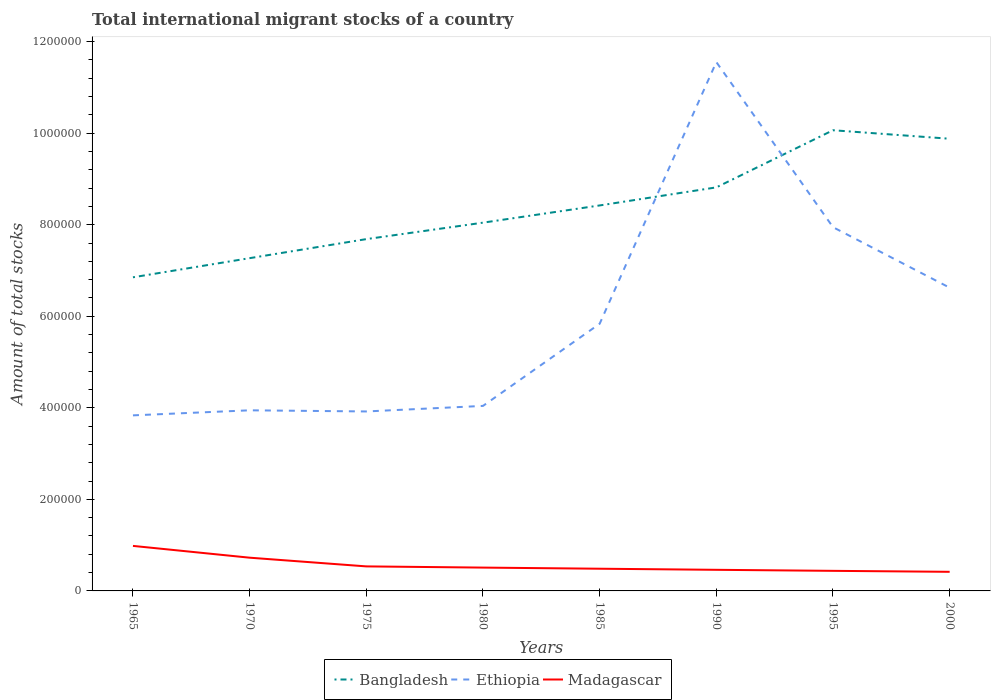How many different coloured lines are there?
Ensure brevity in your answer.  3. Is the number of lines equal to the number of legend labels?
Keep it short and to the point. Yes. Across all years, what is the maximum amount of total stocks in in Madagascar?
Your answer should be very brief. 4.17e+04. In which year was the amount of total stocks in in Ethiopia maximum?
Your answer should be very brief. 1965. What is the total amount of total stocks in in Bangladesh in the graph?
Ensure brevity in your answer.  -3.76e+04. What is the difference between the highest and the second highest amount of total stocks in in Bangladesh?
Ensure brevity in your answer.  3.21e+05. Is the amount of total stocks in in Bangladesh strictly greater than the amount of total stocks in in Ethiopia over the years?
Your response must be concise. No. How many lines are there?
Offer a very short reply. 3. Does the graph contain grids?
Keep it short and to the point. No. What is the title of the graph?
Give a very brief answer. Total international migrant stocks of a country. Does "Cuba" appear as one of the legend labels in the graph?
Ensure brevity in your answer.  No. What is the label or title of the Y-axis?
Your answer should be compact. Amount of total stocks. What is the Amount of total stocks of Bangladesh in 1965?
Give a very brief answer. 6.85e+05. What is the Amount of total stocks in Ethiopia in 1965?
Your answer should be very brief. 3.84e+05. What is the Amount of total stocks in Madagascar in 1965?
Provide a succinct answer. 9.84e+04. What is the Amount of total stocks in Bangladesh in 1970?
Keep it short and to the point. 7.27e+05. What is the Amount of total stocks of Ethiopia in 1970?
Provide a succinct answer. 3.95e+05. What is the Amount of total stocks in Madagascar in 1970?
Ensure brevity in your answer.  7.26e+04. What is the Amount of total stocks of Bangladesh in 1975?
Give a very brief answer. 7.69e+05. What is the Amount of total stocks in Ethiopia in 1975?
Ensure brevity in your answer.  3.92e+05. What is the Amount of total stocks of Madagascar in 1975?
Offer a terse response. 5.36e+04. What is the Amount of total stocks of Bangladesh in 1980?
Your answer should be very brief. 8.05e+05. What is the Amount of total stocks in Ethiopia in 1980?
Provide a succinct answer. 4.04e+05. What is the Amount of total stocks of Madagascar in 1980?
Provide a succinct answer. 5.10e+04. What is the Amount of total stocks of Bangladesh in 1985?
Give a very brief answer. 8.42e+05. What is the Amount of total stocks of Ethiopia in 1985?
Your answer should be very brief. 5.84e+05. What is the Amount of total stocks of Madagascar in 1985?
Make the answer very short. 4.85e+04. What is the Amount of total stocks in Bangladesh in 1990?
Ensure brevity in your answer.  8.82e+05. What is the Amount of total stocks of Ethiopia in 1990?
Your answer should be compact. 1.16e+06. What is the Amount of total stocks of Madagascar in 1990?
Provide a succinct answer. 4.61e+04. What is the Amount of total stocks in Bangladesh in 1995?
Give a very brief answer. 1.01e+06. What is the Amount of total stocks in Ethiopia in 1995?
Provide a succinct answer. 7.95e+05. What is the Amount of total stocks of Madagascar in 1995?
Provide a succinct answer. 4.39e+04. What is the Amount of total stocks in Bangladesh in 2000?
Offer a very short reply. 9.88e+05. What is the Amount of total stocks of Ethiopia in 2000?
Provide a short and direct response. 6.62e+05. What is the Amount of total stocks of Madagascar in 2000?
Ensure brevity in your answer.  4.17e+04. Across all years, what is the maximum Amount of total stocks of Bangladesh?
Make the answer very short. 1.01e+06. Across all years, what is the maximum Amount of total stocks in Ethiopia?
Give a very brief answer. 1.16e+06. Across all years, what is the maximum Amount of total stocks of Madagascar?
Provide a succinct answer. 9.84e+04. Across all years, what is the minimum Amount of total stocks in Bangladesh?
Give a very brief answer. 6.85e+05. Across all years, what is the minimum Amount of total stocks in Ethiopia?
Provide a succinct answer. 3.84e+05. Across all years, what is the minimum Amount of total stocks of Madagascar?
Your answer should be compact. 4.17e+04. What is the total Amount of total stocks in Bangladesh in the graph?
Offer a terse response. 6.70e+06. What is the total Amount of total stocks in Ethiopia in the graph?
Make the answer very short. 4.77e+06. What is the total Amount of total stocks in Madagascar in the graph?
Your answer should be very brief. 4.56e+05. What is the difference between the Amount of total stocks of Bangladesh in 1965 and that in 1970?
Provide a short and direct response. -4.18e+04. What is the difference between the Amount of total stocks in Ethiopia in 1965 and that in 1970?
Offer a terse response. -1.10e+04. What is the difference between the Amount of total stocks in Madagascar in 1965 and that in 1970?
Provide a succinct answer. 2.58e+04. What is the difference between the Amount of total stocks in Bangladesh in 1965 and that in 1975?
Keep it short and to the point. -8.34e+04. What is the difference between the Amount of total stocks of Ethiopia in 1965 and that in 1975?
Keep it short and to the point. -8531. What is the difference between the Amount of total stocks in Madagascar in 1965 and that in 1975?
Keep it short and to the point. 4.48e+04. What is the difference between the Amount of total stocks in Bangladesh in 1965 and that in 1980?
Provide a short and direct response. -1.19e+05. What is the difference between the Amount of total stocks of Ethiopia in 1965 and that in 1980?
Offer a very short reply. -2.06e+04. What is the difference between the Amount of total stocks in Madagascar in 1965 and that in 1980?
Make the answer very short. 4.74e+04. What is the difference between the Amount of total stocks of Bangladesh in 1965 and that in 1985?
Keep it short and to the point. -1.57e+05. What is the difference between the Amount of total stocks of Ethiopia in 1965 and that in 1985?
Offer a very short reply. -2.00e+05. What is the difference between the Amount of total stocks of Madagascar in 1965 and that in 1985?
Give a very brief answer. 4.99e+04. What is the difference between the Amount of total stocks in Bangladesh in 1965 and that in 1990?
Provide a short and direct response. -1.96e+05. What is the difference between the Amount of total stocks in Ethiopia in 1965 and that in 1990?
Give a very brief answer. -7.72e+05. What is the difference between the Amount of total stocks of Madagascar in 1965 and that in 1990?
Keep it short and to the point. 5.22e+04. What is the difference between the Amount of total stocks in Bangladesh in 1965 and that in 1995?
Your response must be concise. -3.21e+05. What is the difference between the Amount of total stocks of Ethiopia in 1965 and that in 1995?
Give a very brief answer. -4.11e+05. What is the difference between the Amount of total stocks of Madagascar in 1965 and that in 1995?
Ensure brevity in your answer.  5.45e+04. What is the difference between the Amount of total stocks of Bangladesh in 1965 and that in 2000?
Offer a very short reply. -3.03e+05. What is the difference between the Amount of total stocks of Ethiopia in 1965 and that in 2000?
Offer a very short reply. -2.79e+05. What is the difference between the Amount of total stocks in Madagascar in 1965 and that in 2000?
Provide a short and direct response. 5.66e+04. What is the difference between the Amount of total stocks of Bangladesh in 1970 and that in 1975?
Your response must be concise. -4.16e+04. What is the difference between the Amount of total stocks in Ethiopia in 1970 and that in 1975?
Keep it short and to the point. 2500. What is the difference between the Amount of total stocks of Madagascar in 1970 and that in 1975?
Offer a very short reply. 1.90e+04. What is the difference between the Amount of total stocks in Bangladesh in 1970 and that in 1980?
Provide a short and direct response. -7.75e+04. What is the difference between the Amount of total stocks of Ethiopia in 1970 and that in 1980?
Ensure brevity in your answer.  -9610. What is the difference between the Amount of total stocks in Madagascar in 1970 and that in 1980?
Make the answer very short. 2.16e+04. What is the difference between the Amount of total stocks of Bangladesh in 1970 and that in 1985?
Keep it short and to the point. -1.15e+05. What is the difference between the Amount of total stocks of Ethiopia in 1970 and that in 1985?
Your response must be concise. -1.89e+05. What is the difference between the Amount of total stocks in Madagascar in 1970 and that in 1985?
Offer a terse response. 2.41e+04. What is the difference between the Amount of total stocks in Bangladesh in 1970 and that in 1990?
Your response must be concise. -1.55e+05. What is the difference between the Amount of total stocks of Ethiopia in 1970 and that in 1990?
Offer a very short reply. -7.61e+05. What is the difference between the Amount of total stocks in Madagascar in 1970 and that in 1990?
Make the answer very short. 2.65e+04. What is the difference between the Amount of total stocks of Bangladesh in 1970 and that in 1995?
Provide a succinct answer. -2.79e+05. What is the difference between the Amount of total stocks of Ethiopia in 1970 and that in 1995?
Your response must be concise. -4.00e+05. What is the difference between the Amount of total stocks of Madagascar in 1970 and that in 1995?
Keep it short and to the point. 2.87e+04. What is the difference between the Amount of total stocks of Bangladesh in 1970 and that in 2000?
Provide a short and direct response. -2.61e+05. What is the difference between the Amount of total stocks of Ethiopia in 1970 and that in 2000?
Provide a short and direct response. -2.68e+05. What is the difference between the Amount of total stocks in Madagascar in 1970 and that in 2000?
Provide a short and direct response. 3.09e+04. What is the difference between the Amount of total stocks of Bangladesh in 1975 and that in 1980?
Ensure brevity in your answer.  -3.59e+04. What is the difference between the Amount of total stocks in Ethiopia in 1975 and that in 1980?
Your response must be concise. -1.21e+04. What is the difference between the Amount of total stocks of Madagascar in 1975 and that in 1980?
Your answer should be compact. 2614. What is the difference between the Amount of total stocks in Bangladesh in 1975 and that in 1985?
Keep it short and to the point. -7.36e+04. What is the difference between the Amount of total stocks in Ethiopia in 1975 and that in 1985?
Make the answer very short. -1.92e+05. What is the difference between the Amount of total stocks in Madagascar in 1975 and that in 1985?
Your answer should be very brief. 5101. What is the difference between the Amount of total stocks in Bangladesh in 1975 and that in 1990?
Offer a very short reply. -1.13e+05. What is the difference between the Amount of total stocks in Ethiopia in 1975 and that in 1990?
Provide a succinct answer. -7.63e+05. What is the difference between the Amount of total stocks in Madagascar in 1975 and that in 1990?
Offer a terse response. 7466. What is the difference between the Amount of total stocks of Bangladesh in 1975 and that in 1995?
Offer a terse response. -2.38e+05. What is the difference between the Amount of total stocks in Ethiopia in 1975 and that in 1995?
Your answer should be very brief. -4.03e+05. What is the difference between the Amount of total stocks in Madagascar in 1975 and that in 1995?
Offer a terse response. 9716. What is the difference between the Amount of total stocks in Bangladesh in 1975 and that in 2000?
Keep it short and to the point. -2.19e+05. What is the difference between the Amount of total stocks of Ethiopia in 1975 and that in 2000?
Your response must be concise. -2.70e+05. What is the difference between the Amount of total stocks in Madagascar in 1975 and that in 2000?
Give a very brief answer. 1.19e+04. What is the difference between the Amount of total stocks of Bangladesh in 1980 and that in 1985?
Make the answer very short. -3.76e+04. What is the difference between the Amount of total stocks of Ethiopia in 1980 and that in 1985?
Make the answer very short. -1.79e+05. What is the difference between the Amount of total stocks of Madagascar in 1980 and that in 1985?
Your answer should be very brief. 2487. What is the difference between the Amount of total stocks of Bangladesh in 1980 and that in 1990?
Provide a succinct answer. -7.71e+04. What is the difference between the Amount of total stocks of Ethiopia in 1980 and that in 1990?
Your response must be concise. -7.51e+05. What is the difference between the Amount of total stocks in Madagascar in 1980 and that in 1990?
Ensure brevity in your answer.  4852. What is the difference between the Amount of total stocks of Bangladesh in 1980 and that in 1995?
Make the answer very short. -2.02e+05. What is the difference between the Amount of total stocks of Ethiopia in 1980 and that in 1995?
Your answer should be very brief. -3.90e+05. What is the difference between the Amount of total stocks of Madagascar in 1980 and that in 1995?
Ensure brevity in your answer.  7102. What is the difference between the Amount of total stocks in Bangladesh in 1980 and that in 2000?
Offer a terse response. -1.83e+05. What is the difference between the Amount of total stocks in Ethiopia in 1980 and that in 2000?
Keep it short and to the point. -2.58e+05. What is the difference between the Amount of total stocks of Madagascar in 1980 and that in 2000?
Your response must be concise. 9242. What is the difference between the Amount of total stocks in Bangladesh in 1985 and that in 1990?
Your answer should be compact. -3.95e+04. What is the difference between the Amount of total stocks of Ethiopia in 1985 and that in 1990?
Offer a terse response. -5.72e+05. What is the difference between the Amount of total stocks in Madagascar in 1985 and that in 1990?
Provide a short and direct response. 2365. What is the difference between the Amount of total stocks of Bangladesh in 1985 and that in 1995?
Provide a short and direct response. -1.64e+05. What is the difference between the Amount of total stocks of Ethiopia in 1985 and that in 1995?
Give a very brief answer. -2.11e+05. What is the difference between the Amount of total stocks in Madagascar in 1985 and that in 1995?
Ensure brevity in your answer.  4615. What is the difference between the Amount of total stocks of Bangladesh in 1985 and that in 2000?
Offer a terse response. -1.46e+05. What is the difference between the Amount of total stocks in Ethiopia in 1985 and that in 2000?
Your answer should be very brief. -7.88e+04. What is the difference between the Amount of total stocks in Madagascar in 1985 and that in 2000?
Make the answer very short. 6755. What is the difference between the Amount of total stocks in Bangladesh in 1990 and that in 1995?
Your answer should be very brief. -1.25e+05. What is the difference between the Amount of total stocks in Ethiopia in 1990 and that in 1995?
Your response must be concise. 3.61e+05. What is the difference between the Amount of total stocks of Madagascar in 1990 and that in 1995?
Offer a very short reply. 2250. What is the difference between the Amount of total stocks in Bangladesh in 1990 and that in 2000?
Your response must be concise. -1.06e+05. What is the difference between the Amount of total stocks of Ethiopia in 1990 and that in 2000?
Make the answer very short. 4.93e+05. What is the difference between the Amount of total stocks of Madagascar in 1990 and that in 2000?
Offer a terse response. 4390. What is the difference between the Amount of total stocks in Bangladesh in 1995 and that in 2000?
Give a very brief answer. 1.86e+04. What is the difference between the Amount of total stocks of Ethiopia in 1995 and that in 2000?
Provide a short and direct response. 1.32e+05. What is the difference between the Amount of total stocks in Madagascar in 1995 and that in 2000?
Your answer should be very brief. 2140. What is the difference between the Amount of total stocks of Bangladesh in 1965 and the Amount of total stocks of Ethiopia in 1970?
Your answer should be very brief. 2.91e+05. What is the difference between the Amount of total stocks in Bangladesh in 1965 and the Amount of total stocks in Madagascar in 1970?
Make the answer very short. 6.13e+05. What is the difference between the Amount of total stocks in Ethiopia in 1965 and the Amount of total stocks in Madagascar in 1970?
Offer a terse response. 3.11e+05. What is the difference between the Amount of total stocks in Bangladesh in 1965 and the Amount of total stocks in Ethiopia in 1975?
Keep it short and to the point. 2.93e+05. What is the difference between the Amount of total stocks of Bangladesh in 1965 and the Amount of total stocks of Madagascar in 1975?
Offer a terse response. 6.32e+05. What is the difference between the Amount of total stocks in Ethiopia in 1965 and the Amount of total stocks in Madagascar in 1975?
Ensure brevity in your answer.  3.30e+05. What is the difference between the Amount of total stocks in Bangladesh in 1965 and the Amount of total stocks in Ethiopia in 1980?
Make the answer very short. 2.81e+05. What is the difference between the Amount of total stocks in Bangladesh in 1965 and the Amount of total stocks in Madagascar in 1980?
Keep it short and to the point. 6.34e+05. What is the difference between the Amount of total stocks in Ethiopia in 1965 and the Amount of total stocks in Madagascar in 1980?
Your answer should be very brief. 3.33e+05. What is the difference between the Amount of total stocks in Bangladesh in 1965 and the Amount of total stocks in Ethiopia in 1985?
Keep it short and to the point. 1.02e+05. What is the difference between the Amount of total stocks of Bangladesh in 1965 and the Amount of total stocks of Madagascar in 1985?
Make the answer very short. 6.37e+05. What is the difference between the Amount of total stocks in Ethiopia in 1965 and the Amount of total stocks in Madagascar in 1985?
Your response must be concise. 3.35e+05. What is the difference between the Amount of total stocks of Bangladesh in 1965 and the Amount of total stocks of Ethiopia in 1990?
Provide a short and direct response. -4.70e+05. What is the difference between the Amount of total stocks in Bangladesh in 1965 and the Amount of total stocks in Madagascar in 1990?
Your answer should be very brief. 6.39e+05. What is the difference between the Amount of total stocks of Ethiopia in 1965 and the Amount of total stocks of Madagascar in 1990?
Ensure brevity in your answer.  3.37e+05. What is the difference between the Amount of total stocks of Bangladesh in 1965 and the Amount of total stocks of Ethiopia in 1995?
Your answer should be compact. -1.10e+05. What is the difference between the Amount of total stocks of Bangladesh in 1965 and the Amount of total stocks of Madagascar in 1995?
Offer a very short reply. 6.41e+05. What is the difference between the Amount of total stocks in Ethiopia in 1965 and the Amount of total stocks in Madagascar in 1995?
Offer a very short reply. 3.40e+05. What is the difference between the Amount of total stocks of Bangladesh in 1965 and the Amount of total stocks of Ethiopia in 2000?
Your answer should be very brief. 2.27e+04. What is the difference between the Amount of total stocks of Bangladesh in 1965 and the Amount of total stocks of Madagascar in 2000?
Provide a short and direct response. 6.43e+05. What is the difference between the Amount of total stocks in Ethiopia in 1965 and the Amount of total stocks in Madagascar in 2000?
Provide a succinct answer. 3.42e+05. What is the difference between the Amount of total stocks in Bangladesh in 1970 and the Amount of total stocks in Ethiopia in 1975?
Ensure brevity in your answer.  3.35e+05. What is the difference between the Amount of total stocks of Bangladesh in 1970 and the Amount of total stocks of Madagascar in 1975?
Your response must be concise. 6.73e+05. What is the difference between the Amount of total stocks of Ethiopia in 1970 and the Amount of total stocks of Madagascar in 1975?
Offer a very short reply. 3.41e+05. What is the difference between the Amount of total stocks in Bangladesh in 1970 and the Amount of total stocks in Ethiopia in 1980?
Your response must be concise. 3.23e+05. What is the difference between the Amount of total stocks in Bangladesh in 1970 and the Amount of total stocks in Madagascar in 1980?
Provide a succinct answer. 6.76e+05. What is the difference between the Amount of total stocks of Ethiopia in 1970 and the Amount of total stocks of Madagascar in 1980?
Provide a succinct answer. 3.44e+05. What is the difference between the Amount of total stocks of Bangladesh in 1970 and the Amount of total stocks of Ethiopia in 1985?
Your answer should be very brief. 1.43e+05. What is the difference between the Amount of total stocks in Bangladesh in 1970 and the Amount of total stocks in Madagascar in 1985?
Your answer should be very brief. 6.78e+05. What is the difference between the Amount of total stocks of Ethiopia in 1970 and the Amount of total stocks of Madagascar in 1985?
Make the answer very short. 3.46e+05. What is the difference between the Amount of total stocks in Bangladesh in 1970 and the Amount of total stocks in Ethiopia in 1990?
Provide a succinct answer. -4.28e+05. What is the difference between the Amount of total stocks in Bangladesh in 1970 and the Amount of total stocks in Madagascar in 1990?
Offer a very short reply. 6.81e+05. What is the difference between the Amount of total stocks of Ethiopia in 1970 and the Amount of total stocks of Madagascar in 1990?
Make the answer very short. 3.48e+05. What is the difference between the Amount of total stocks of Bangladesh in 1970 and the Amount of total stocks of Ethiopia in 1995?
Provide a succinct answer. -6.77e+04. What is the difference between the Amount of total stocks in Bangladesh in 1970 and the Amount of total stocks in Madagascar in 1995?
Your answer should be compact. 6.83e+05. What is the difference between the Amount of total stocks of Ethiopia in 1970 and the Amount of total stocks of Madagascar in 1995?
Offer a very short reply. 3.51e+05. What is the difference between the Amount of total stocks of Bangladesh in 1970 and the Amount of total stocks of Ethiopia in 2000?
Your answer should be very brief. 6.45e+04. What is the difference between the Amount of total stocks in Bangladesh in 1970 and the Amount of total stocks in Madagascar in 2000?
Give a very brief answer. 6.85e+05. What is the difference between the Amount of total stocks of Ethiopia in 1970 and the Amount of total stocks of Madagascar in 2000?
Provide a succinct answer. 3.53e+05. What is the difference between the Amount of total stocks in Bangladesh in 1975 and the Amount of total stocks in Ethiopia in 1980?
Make the answer very short. 3.64e+05. What is the difference between the Amount of total stocks of Bangladesh in 1975 and the Amount of total stocks of Madagascar in 1980?
Your response must be concise. 7.18e+05. What is the difference between the Amount of total stocks of Ethiopia in 1975 and the Amount of total stocks of Madagascar in 1980?
Ensure brevity in your answer.  3.41e+05. What is the difference between the Amount of total stocks in Bangladesh in 1975 and the Amount of total stocks in Ethiopia in 1985?
Ensure brevity in your answer.  1.85e+05. What is the difference between the Amount of total stocks in Bangladesh in 1975 and the Amount of total stocks in Madagascar in 1985?
Your response must be concise. 7.20e+05. What is the difference between the Amount of total stocks of Ethiopia in 1975 and the Amount of total stocks of Madagascar in 1985?
Give a very brief answer. 3.44e+05. What is the difference between the Amount of total stocks in Bangladesh in 1975 and the Amount of total stocks in Ethiopia in 1990?
Your answer should be compact. -3.87e+05. What is the difference between the Amount of total stocks in Bangladesh in 1975 and the Amount of total stocks in Madagascar in 1990?
Your answer should be very brief. 7.22e+05. What is the difference between the Amount of total stocks of Ethiopia in 1975 and the Amount of total stocks of Madagascar in 1990?
Offer a terse response. 3.46e+05. What is the difference between the Amount of total stocks of Bangladesh in 1975 and the Amount of total stocks of Ethiopia in 1995?
Offer a very short reply. -2.61e+04. What is the difference between the Amount of total stocks in Bangladesh in 1975 and the Amount of total stocks in Madagascar in 1995?
Offer a very short reply. 7.25e+05. What is the difference between the Amount of total stocks of Ethiopia in 1975 and the Amount of total stocks of Madagascar in 1995?
Your response must be concise. 3.48e+05. What is the difference between the Amount of total stocks in Bangladesh in 1975 and the Amount of total stocks in Ethiopia in 2000?
Ensure brevity in your answer.  1.06e+05. What is the difference between the Amount of total stocks in Bangladesh in 1975 and the Amount of total stocks in Madagascar in 2000?
Provide a short and direct response. 7.27e+05. What is the difference between the Amount of total stocks of Ethiopia in 1975 and the Amount of total stocks of Madagascar in 2000?
Offer a very short reply. 3.50e+05. What is the difference between the Amount of total stocks of Bangladesh in 1980 and the Amount of total stocks of Ethiopia in 1985?
Offer a very short reply. 2.21e+05. What is the difference between the Amount of total stocks in Bangladesh in 1980 and the Amount of total stocks in Madagascar in 1985?
Provide a succinct answer. 7.56e+05. What is the difference between the Amount of total stocks in Ethiopia in 1980 and the Amount of total stocks in Madagascar in 1985?
Provide a short and direct response. 3.56e+05. What is the difference between the Amount of total stocks of Bangladesh in 1980 and the Amount of total stocks of Ethiopia in 1990?
Ensure brevity in your answer.  -3.51e+05. What is the difference between the Amount of total stocks of Bangladesh in 1980 and the Amount of total stocks of Madagascar in 1990?
Provide a succinct answer. 7.58e+05. What is the difference between the Amount of total stocks in Ethiopia in 1980 and the Amount of total stocks in Madagascar in 1990?
Make the answer very short. 3.58e+05. What is the difference between the Amount of total stocks in Bangladesh in 1980 and the Amount of total stocks in Ethiopia in 1995?
Keep it short and to the point. 9859. What is the difference between the Amount of total stocks of Bangladesh in 1980 and the Amount of total stocks of Madagascar in 1995?
Provide a short and direct response. 7.61e+05. What is the difference between the Amount of total stocks in Ethiopia in 1980 and the Amount of total stocks in Madagascar in 1995?
Make the answer very short. 3.60e+05. What is the difference between the Amount of total stocks of Bangladesh in 1980 and the Amount of total stocks of Ethiopia in 2000?
Ensure brevity in your answer.  1.42e+05. What is the difference between the Amount of total stocks in Bangladesh in 1980 and the Amount of total stocks in Madagascar in 2000?
Offer a terse response. 7.63e+05. What is the difference between the Amount of total stocks of Ethiopia in 1980 and the Amount of total stocks of Madagascar in 2000?
Provide a short and direct response. 3.62e+05. What is the difference between the Amount of total stocks of Bangladesh in 1985 and the Amount of total stocks of Ethiopia in 1990?
Offer a terse response. -3.13e+05. What is the difference between the Amount of total stocks of Bangladesh in 1985 and the Amount of total stocks of Madagascar in 1990?
Make the answer very short. 7.96e+05. What is the difference between the Amount of total stocks in Ethiopia in 1985 and the Amount of total stocks in Madagascar in 1990?
Your answer should be very brief. 5.38e+05. What is the difference between the Amount of total stocks of Bangladesh in 1985 and the Amount of total stocks of Ethiopia in 1995?
Provide a succinct answer. 4.75e+04. What is the difference between the Amount of total stocks in Bangladesh in 1985 and the Amount of total stocks in Madagascar in 1995?
Provide a succinct answer. 7.98e+05. What is the difference between the Amount of total stocks of Ethiopia in 1985 and the Amount of total stocks of Madagascar in 1995?
Your answer should be compact. 5.40e+05. What is the difference between the Amount of total stocks in Bangladesh in 1985 and the Amount of total stocks in Ethiopia in 2000?
Provide a short and direct response. 1.80e+05. What is the difference between the Amount of total stocks in Bangladesh in 1985 and the Amount of total stocks in Madagascar in 2000?
Your response must be concise. 8.00e+05. What is the difference between the Amount of total stocks of Ethiopia in 1985 and the Amount of total stocks of Madagascar in 2000?
Offer a very short reply. 5.42e+05. What is the difference between the Amount of total stocks in Bangladesh in 1990 and the Amount of total stocks in Ethiopia in 1995?
Ensure brevity in your answer.  8.70e+04. What is the difference between the Amount of total stocks in Bangladesh in 1990 and the Amount of total stocks in Madagascar in 1995?
Your answer should be very brief. 8.38e+05. What is the difference between the Amount of total stocks of Ethiopia in 1990 and the Amount of total stocks of Madagascar in 1995?
Offer a very short reply. 1.11e+06. What is the difference between the Amount of total stocks in Bangladesh in 1990 and the Amount of total stocks in Ethiopia in 2000?
Your response must be concise. 2.19e+05. What is the difference between the Amount of total stocks of Bangladesh in 1990 and the Amount of total stocks of Madagascar in 2000?
Provide a succinct answer. 8.40e+05. What is the difference between the Amount of total stocks of Ethiopia in 1990 and the Amount of total stocks of Madagascar in 2000?
Ensure brevity in your answer.  1.11e+06. What is the difference between the Amount of total stocks in Bangladesh in 1995 and the Amount of total stocks in Ethiopia in 2000?
Your answer should be very brief. 3.44e+05. What is the difference between the Amount of total stocks of Bangladesh in 1995 and the Amount of total stocks of Madagascar in 2000?
Offer a terse response. 9.65e+05. What is the difference between the Amount of total stocks in Ethiopia in 1995 and the Amount of total stocks in Madagascar in 2000?
Give a very brief answer. 7.53e+05. What is the average Amount of total stocks in Bangladesh per year?
Offer a terse response. 8.38e+05. What is the average Amount of total stocks in Ethiopia per year?
Offer a terse response. 5.96e+05. What is the average Amount of total stocks of Madagascar per year?
Give a very brief answer. 5.70e+04. In the year 1965, what is the difference between the Amount of total stocks of Bangladesh and Amount of total stocks of Ethiopia?
Keep it short and to the point. 3.02e+05. In the year 1965, what is the difference between the Amount of total stocks in Bangladesh and Amount of total stocks in Madagascar?
Your answer should be compact. 5.87e+05. In the year 1965, what is the difference between the Amount of total stocks of Ethiopia and Amount of total stocks of Madagascar?
Provide a succinct answer. 2.85e+05. In the year 1970, what is the difference between the Amount of total stocks in Bangladesh and Amount of total stocks in Ethiopia?
Provide a short and direct response. 3.32e+05. In the year 1970, what is the difference between the Amount of total stocks of Bangladesh and Amount of total stocks of Madagascar?
Your response must be concise. 6.54e+05. In the year 1970, what is the difference between the Amount of total stocks in Ethiopia and Amount of total stocks in Madagascar?
Provide a short and direct response. 3.22e+05. In the year 1975, what is the difference between the Amount of total stocks of Bangladesh and Amount of total stocks of Ethiopia?
Your answer should be very brief. 3.76e+05. In the year 1975, what is the difference between the Amount of total stocks in Bangladesh and Amount of total stocks in Madagascar?
Provide a succinct answer. 7.15e+05. In the year 1975, what is the difference between the Amount of total stocks in Ethiopia and Amount of total stocks in Madagascar?
Give a very brief answer. 3.38e+05. In the year 1980, what is the difference between the Amount of total stocks of Bangladesh and Amount of total stocks of Ethiopia?
Your answer should be compact. 4.00e+05. In the year 1980, what is the difference between the Amount of total stocks in Bangladesh and Amount of total stocks in Madagascar?
Your answer should be compact. 7.54e+05. In the year 1980, what is the difference between the Amount of total stocks of Ethiopia and Amount of total stocks of Madagascar?
Provide a short and direct response. 3.53e+05. In the year 1985, what is the difference between the Amount of total stocks in Bangladesh and Amount of total stocks in Ethiopia?
Ensure brevity in your answer.  2.58e+05. In the year 1985, what is the difference between the Amount of total stocks in Bangladesh and Amount of total stocks in Madagascar?
Your answer should be very brief. 7.94e+05. In the year 1985, what is the difference between the Amount of total stocks of Ethiopia and Amount of total stocks of Madagascar?
Your response must be concise. 5.35e+05. In the year 1990, what is the difference between the Amount of total stocks of Bangladesh and Amount of total stocks of Ethiopia?
Provide a succinct answer. -2.74e+05. In the year 1990, what is the difference between the Amount of total stocks in Bangladesh and Amount of total stocks in Madagascar?
Your response must be concise. 8.35e+05. In the year 1990, what is the difference between the Amount of total stocks of Ethiopia and Amount of total stocks of Madagascar?
Ensure brevity in your answer.  1.11e+06. In the year 1995, what is the difference between the Amount of total stocks of Bangladesh and Amount of total stocks of Ethiopia?
Your answer should be compact. 2.12e+05. In the year 1995, what is the difference between the Amount of total stocks in Bangladesh and Amount of total stocks in Madagascar?
Make the answer very short. 9.63e+05. In the year 1995, what is the difference between the Amount of total stocks in Ethiopia and Amount of total stocks in Madagascar?
Give a very brief answer. 7.51e+05. In the year 2000, what is the difference between the Amount of total stocks of Bangladesh and Amount of total stocks of Ethiopia?
Your response must be concise. 3.25e+05. In the year 2000, what is the difference between the Amount of total stocks of Bangladesh and Amount of total stocks of Madagascar?
Offer a very short reply. 9.46e+05. In the year 2000, what is the difference between the Amount of total stocks in Ethiopia and Amount of total stocks in Madagascar?
Give a very brief answer. 6.21e+05. What is the ratio of the Amount of total stocks of Bangladesh in 1965 to that in 1970?
Offer a terse response. 0.94. What is the ratio of the Amount of total stocks of Madagascar in 1965 to that in 1970?
Provide a succinct answer. 1.35. What is the ratio of the Amount of total stocks in Bangladesh in 1965 to that in 1975?
Provide a short and direct response. 0.89. What is the ratio of the Amount of total stocks in Ethiopia in 1965 to that in 1975?
Your response must be concise. 0.98. What is the ratio of the Amount of total stocks of Madagascar in 1965 to that in 1975?
Your answer should be compact. 1.84. What is the ratio of the Amount of total stocks in Bangladesh in 1965 to that in 1980?
Make the answer very short. 0.85. What is the ratio of the Amount of total stocks of Ethiopia in 1965 to that in 1980?
Ensure brevity in your answer.  0.95. What is the ratio of the Amount of total stocks of Madagascar in 1965 to that in 1980?
Offer a terse response. 1.93. What is the ratio of the Amount of total stocks of Bangladesh in 1965 to that in 1985?
Offer a terse response. 0.81. What is the ratio of the Amount of total stocks in Ethiopia in 1965 to that in 1985?
Offer a terse response. 0.66. What is the ratio of the Amount of total stocks in Madagascar in 1965 to that in 1985?
Make the answer very short. 2.03. What is the ratio of the Amount of total stocks of Bangladesh in 1965 to that in 1990?
Ensure brevity in your answer.  0.78. What is the ratio of the Amount of total stocks of Ethiopia in 1965 to that in 1990?
Give a very brief answer. 0.33. What is the ratio of the Amount of total stocks of Madagascar in 1965 to that in 1990?
Your response must be concise. 2.13. What is the ratio of the Amount of total stocks of Bangladesh in 1965 to that in 1995?
Provide a short and direct response. 0.68. What is the ratio of the Amount of total stocks of Ethiopia in 1965 to that in 1995?
Your answer should be compact. 0.48. What is the ratio of the Amount of total stocks of Madagascar in 1965 to that in 1995?
Ensure brevity in your answer.  2.24. What is the ratio of the Amount of total stocks of Bangladesh in 1965 to that in 2000?
Your response must be concise. 0.69. What is the ratio of the Amount of total stocks of Ethiopia in 1965 to that in 2000?
Give a very brief answer. 0.58. What is the ratio of the Amount of total stocks of Madagascar in 1965 to that in 2000?
Your response must be concise. 2.36. What is the ratio of the Amount of total stocks in Bangladesh in 1970 to that in 1975?
Give a very brief answer. 0.95. What is the ratio of the Amount of total stocks of Ethiopia in 1970 to that in 1975?
Provide a short and direct response. 1.01. What is the ratio of the Amount of total stocks in Madagascar in 1970 to that in 1975?
Provide a short and direct response. 1.35. What is the ratio of the Amount of total stocks in Bangladesh in 1970 to that in 1980?
Give a very brief answer. 0.9. What is the ratio of the Amount of total stocks of Ethiopia in 1970 to that in 1980?
Offer a very short reply. 0.98. What is the ratio of the Amount of total stocks in Madagascar in 1970 to that in 1980?
Provide a succinct answer. 1.42. What is the ratio of the Amount of total stocks of Bangladesh in 1970 to that in 1985?
Offer a terse response. 0.86. What is the ratio of the Amount of total stocks of Ethiopia in 1970 to that in 1985?
Your response must be concise. 0.68. What is the ratio of the Amount of total stocks of Madagascar in 1970 to that in 1985?
Your response must be concise. 1.5. What is the ratio of the Amount of total stocks in Bangladesh in 1970 to that in 1990?
Keep it short and to the point. 0.82. What is the ratio of the Amount of total stocks in Ethiopia in 1970 to that in 1990?
Make the answer very short. 0.34. What is the ratio of the Amount of total stocks of Madagascar in 1970 to that in 1990?
Give a very brief answer. 1.57. What is the ratio of the Amount of total stocks in Bangladesh in 1970 to that in 1995?
Provide a succinct answer. 0.72. What is the ratio of the Amount of total stocks in Ethiopia in 1970 to that in 1995?
Provide a succinct answer. 0.5. What is the ratio of the Amount of total stocks of Madagascar in 1970 to that in 1995?
Offer a terse response. 1.65. What is the ratio of the Amount of total stocks in Bangladesh in 1970 to that in 2000?
Offer a very short reply. 0.74. What is the ratio of the Amount of total stocks in Ethiopia in 1970 to that in 2000?
Give a very brief answer. 0.6. What is the ratio of the Amount of total stocks in Madagascar in 1970 to that in 2000?
Ensure brevity in your answer.  1.74. What is the ratio of the Amount of total stocks of Bangladesh in 1975 to that in 1980?
Offer a very short reply. 0.96. What is the ratio of the Amount of total stocks in Ethiopia in 1975 to that in 1980?
Your response must be concise. 0.97. What is the ratio of the Amount of total stocks in Madagascar in 1975 to that in 1980?
Provide a short and direct response. 1.05. What is the ratio of the Amount of total stocks in Bangladesh in 1975 to that in 1985?
Provide a succinct answer. 0.91. What is the ratio of the Amount of total stocks of Ethiopia in 1975 to that in 1985?
Offer a very short reply. 0.67. What is the ratio of the Amount of total stocks of Madagascar in 1975 to that in 1985?
Give a very brief answer. 1.11. What is the ratio of the Amount of total stocks of Bangladesh in 1975 to that in 1990?
Give a very brief answer. 0.87. What is the ratio of the Amount of total stocks of Ethiopia in 1975 to that in 1990?
Your answer should be compact. 0.34. What is the ratio of the Amount of total stocks in Madagascar in 1975 to that in 1990?
Offer a very short reply. 1.16. What is the ratio of the Amount of total stocks in Bangladesh in 1975 to that in 1995?
Your response must be concise. 0.76. What is the ratio of the Amount of total stocks in Ethiopia in 1975 to that in 1995?
Offer a terse response. 0.49. What is the ratio of the Amount of total stocks in Madagascar in 1975 to that in 1995?
Your answer should be very brief. 1.22. What is the ratio of the Amount of total stocks in Bangladesh in 1975 to that in 2000?
Ensure brevity in your answer.  0.78. What is the ratio of the Amount of total stocks of Ethiopia in 1975 to that in 2000?
Offer a terse response. 0.59. What is the ratio of the Amount of total stocks in Madagascar in 1975 to that in 2000?
Give a very brief answer. 1.28. What is the ratio of the Amount of total stocks of Bangladesh in 1980 to that in 1985?
Your answer should be compact. 0.96. What is the ratio of the Amount of total stocks in Ethiopia in 1980 to that in 1985?
Your response must be concise. 0.69. What is the ratio of the Amount of total stocks of Madagascar in 1980 to that in 1985?
Give a very brief answer. 1.05. What is the ratio of the Amount of total stocks of Bangladesh in 1980 to that in 1990?
Your response must be concise. 0.91. What is the ratio of the Amount of total stocks in Ethiopia in 1980 to that in 1990?
Provide a succinct answer. 0.35. What is the ratio of the Amount of total stocks in Madagascar in 1980 to that in 1990?
Your answer should be very brief. 1.11. What is the ratio of the Amount of total stocks of Bangladesh in 1980 to that in 1995?
Offer a terse response. 0.8. What is the ratio of the Amount of total stocks of Ethiopia in 1980 to that in 1995?
Provide a short and direct response. 0.51. What is the ratio of the Amount of total stocks in Madagascar in 1980 to that in 1995?
Your response must be concise. 1.16. What is the ratio of the Amount of total stocks of Bangladesh in 1980 to that in 2000?
Make the answer very short. 0.81. What is the ratio of the Amount of total stocks of Ethiopia in 1980 to that in 2000?
Make the answer very short. 0.61. What is the ratio of the Amount of total stocks in Madagascar in 1980 to that in 2000?
Make the answer very short. 1.22. What is the ratio of the Amount of total stocks of Bangladesh in 1985 to that in 1990?
Your answer should be very brief. 0.96. What is the ratio of the Amount of total stocks of Ethiopia in 1985 to that in 1990?
Offer a very short reply. 0.51. What is the ratio of the Amount of total stocks in Madagascar in 1985 to that in 1990?
Offer a terse response. 1.05. What is the ratio of the Amount of total stocks of Bangladesh in 1985 to that in 1995?
Make the answer very short. 0.84. What is the ratio of the Amount of total stocks of Ethiopia in 1985 to that in 1995?
Provide a short and direct response. 0.73. What is the ratio of the Amount of total stocks in Madagascar in 1985 to that in 1995?
Give a very brief answer. 1.11. What is the ratio of the Amount of total stocks of Bangladesh in 1985 to that in 2000?
Provide a short and direct response. 0.85. What is the ratio of the Amount of total stocks in Ethiopia in 1985 to that in 2000?
Offer a very short reply. 0.88. What is the ratio of the Amount of total stocks of Madagascar in 1985 to that in 2000?
Offer a very short reply. 1.16. What is the ratio of the Amount of total stocks in Bangladesh in 1990 to that in 1995?
Provide a succinct answer. 0.88. What is the ratio of the Amount of total stocks in Ethiopia in 1990 to that in 1995?
Your answer should be compact. 1.45. What is the ratio of the Amount of total stocks of Madagascar in 1990 to that in 1995?
Your answer should be very brief. 1.05. What is the ratio of the Amount of total stocks of Bangladesh in 1990 to that in 2000?
Keep it short and to the point. 0.89. What is the ratio of the Amount of total stocks of Ethiopia in 1990 to that in 2000?
Your response must be concise. 1.74. What is the ratio of the Amount of total stocks of Madagascar in 1990 to that in 2000?
Ensure brevity in your answer.  1.11. What is the ratio of the Amount of total stocks of Bangladesh in 1995 to that in 2000?
Offer a very short reply. 1.02. What is the ratio of the Amount of total stocks of Ethiopia in 1995 to that in 2000?
Keep it short and to the point. 1.2. What is the ratio of the Amount of total stocks in Madagascar in 1995 to that in 2000?
Provide a succinct answer. 1.05. What is the difference between the highest and the second highest Amount of total stocks of Bangladesh?
Offer a very short reply. 1.86e+04. What is the difference between the highest and the second highest Amount of total stocks in Ethiopia?
Your answer should be very brief. 3.61e+05. What is the difference between the highest and the second highest Amount of total stocks in Madagascar?
Give a very brief answer. 2.58e+04. What is the difference between the highest and the lowest Amount of total stocks in Bangladesh?
Keep it short and to the point. 3.21e+05. What is the difference between the highest and the lowest Amount of total stocks in Ethiopia?
Keep it short and to the point. 7.72e+05. What is the difference between the highest and the lowest Amount of total stocks of Madagascar?
Your response must be concise. 5.66e+04. 